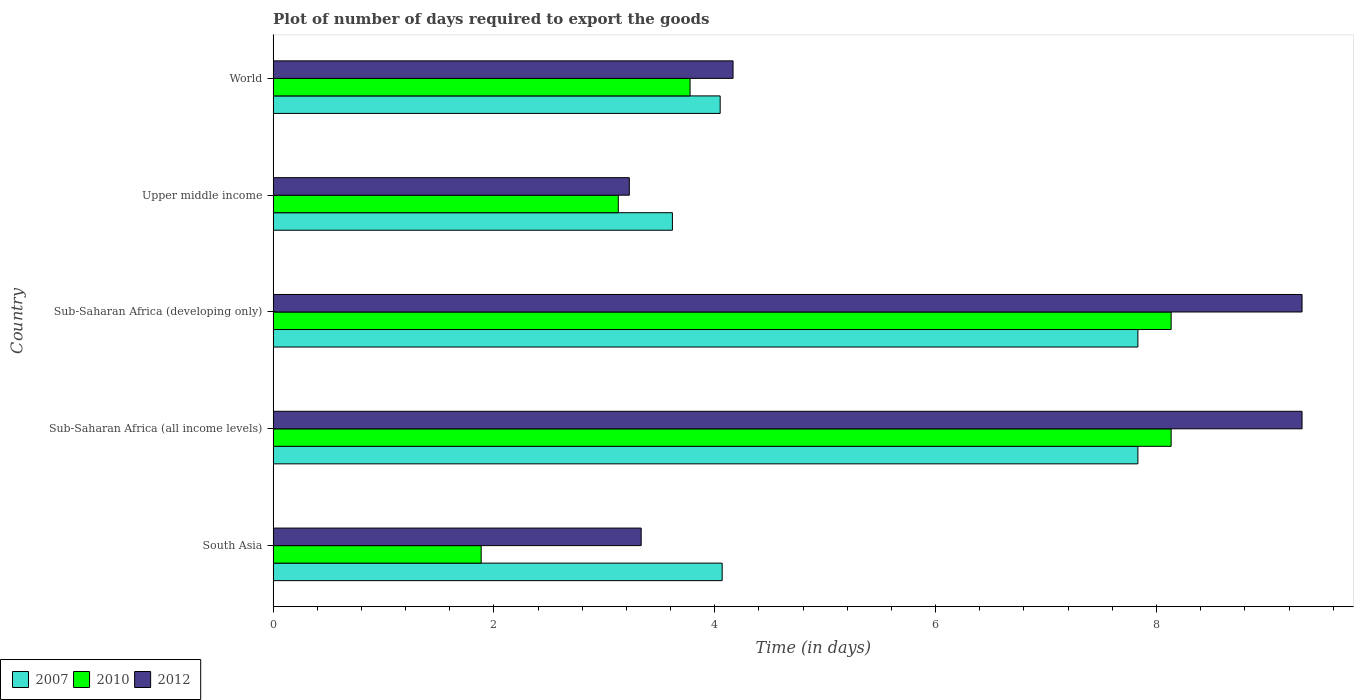How many groups of bars are there?
Give a very brief answer. 5. Are the number of bars per tick equal to the number of legend labels?
Your response must be concise. Yes. Are the number of bars on each tick of the Y-axis equal?
Ensure brevity in your answer.  Yes. How many bars are there on the 3rd tick from the top?
Make the answer very short. 3. How many bars are there on the 2nd tick from the bottom?
Offer a very short reply. 3. What is the label of the 3rd group of bars from the top?
Provide a succinct answer. Sub-Saharan Africa (developing only). In how many cases, is the number of bars for a given country not equal to the number of legend labels?
Your response must be concise. 0. What is the time required to export goods in 2010 in Sub-Saharan Africa (all income levels)?
Give a very brief answer. 8.13. Across all countries, what is the maximum time required to export goods in 2012?
Your answer should be very brief. 9.32. Across all countries, what is the minimum time required to export goods in 2012?
Give a very brief answer. 3.23. In which country was the time required to export goods in 2007 maximum?
Provide a short and direct response. Sub-Saharan Africa (all income levels). What is the total time required to export goods in 2010 in the graph?
Provide a short and direct response. 25.05. What is the difference between the time required to export goods in 2012 in South Asia and the time required to export goods in 2010 in World?
Offer a terse response. -0.44. What is the average time required to export goods in 2010 per country?
Offer a terse response. 5.01. What is the difference between the time required to export goods in 2010 and time required to export goods in 2007 in Sub-Saharan Africa (all income levels)?
Make the answer very short. 0.3. In how many countries, is the time required to export goods in 2007 greater than 9.2 days?
Provide a succinct answer. 0. What is the ratio of the time required to export goods in 2010 in Sub-Saharan Africa (all income levels) to that in Sub-Saharan Africa (developing only)?
Your response must be concise. 1. Is the time required to export goods in 2012 in Sub-Saharan Africa (all income levels) less than that in Sub-Saharan Africa (developing only)?
Give a very brief answer. No. Is the difference between the time required to export goods in 2010 in Sub-Saharan Africa (all income levels) and Upper middle income greater than the difference between the time required to export goods in 2007 in Sub-Saharan Africa (all income levels) and Upper middle income?
Ensure brevity in your answer.  Yes. What is the difference between the highest and the lowest time required to export goods in 2010?
Your answer should be very brief. 6.25. In how many countries, is the time required to export goods in 2007 greater than the average time required to export goods in 2007 taken over all countries?
Make the answer very short. 2. How many countries are there in the graph?
Offer a very short reply. 5. Are the values on the major ticks of X-axis written in scientific E-notation?
Provide a short and direct response. No. How many legend labels are there?
Your answer should be very brief. 3. How are the legend labels stacked?
Your answer should be very brief. Horizontal. What is the title of the graph?
Give a very brief answer. Plot of number of days required to export the goods. What is the label or title of the X-axis?
Offer a terse response. Time (in days). What is the Time (in days) of 2007 in South Asia?
Provide a short and direct response. 4.07. What is the Time (in days) in 2010 in South Asia?
Provide a succinct answer. 1.88. What is the Time (in days) in 2012 in South Asia?
Provide a short and direct response. 3.33. What is the Time (in days) in 2007 in Sub-Saharan Africa (all income levels)?
Offer a very short reply. 7.83. What is the Time (in days) of 2010 in Sub-Saharan Africa (all income levels)?
Provide a succinct answer. 8.13. What is the Time (in days) in 2012 in Sub-Saharan Africa (all income levels)?
Give a very brief answer. 9.32. What is the Time (in days) of 2007 in Sub-Saharan Africa (developing only)?
Offer a terse response. 7.83. What is the Time (in days) of 2010 in Sub-Saharan Africa (developing only)?
Provide a short and direct response. 8.13. What is the Time (in days) of 2012 in Sub-Saharan Africa (developing only)?
Make the answer very short. 9.32. What is the Time (in days) in 2007 in Upper middle income?
Offer a terse response. 3.62. What is the Time (in days) in 2010 in Upper middle income?
Your answer should be compact. 3.13. What is the Time (in days) in 2012 in Upper middle income?
Ensure brevity in your answer.  3.23. What is the Time (in days) of 2007 in World?
Give a very brief answer. 4.05. What is the Time (in days) of 2010 in World?
Your answer should be very brief. 3.78. What is the Time (in days) of 2012 in World?
Your answer should be very brief. 4.17. Across all countries, what is the maximum Time (in days) of 2007?
Make the answer very short. 7.83. Across all countries, what is the maximum Time (in days) in 2010?
Your answer should be very brief. 8.13. Across all countries, what is the maximum Time (in days) of 2012?
Make the answer very short. 9.32. Across all countries, what is the minimum Time (in days) of 2007?
Offer a terse response. 3.62. Across all countries, what is the minimum Time (in days) in 2010?
Keep it short and to the point. 1.88. Across all countries, what is the minimum Time (in days) of 2012?
Offer a terse response. 3.23. What is the total Time (in days) of 2007 in the graph?
Provide a short and direct response. 27.39. What is the total Time (in days) of 2010 in the graph?
Ensure brevity in your answer.  25.05. What is the total Time (in days) of 2012 in the graph?
Provide a succinct answer. 29.36. What is the difference between the Time (in days) of 2007 in South Asia and that in Sub-Saharan Africa (all income levels)?
Give a very brief answer. -3.76. What is the difference between the Time (in days) of 2010 in South Asia and that in Sub-Saharan Africa (all income levels)?
Give a very brief answer. -6.25. What is the difference between the Time (in days) in 2012 in South Asia and that in Sub-Saharan Africa (all income levels)?
Make the answer very short. -5.98. What is the difference between the Time (in days) in 2007 in South Asia and that in Sub-Saharan Africa (developing only)?
Provide a succinct answer. -3.76. What is the difference between the Time (in days) in 2010 in South Asia and that in Sub-Saharan Africa (developing only)?
Offer a terse response. -6.25. What is the difference between the Time (in days) of 2012 in South Asia and that in Sub-Saharan Africa (developing only)?
Provide a succinct answer. -5.98. What is the difference between the Time (in days) in 2007 in South Asia and that in Upper middle income?
Offer a very short reply. 0.45. What is the difference between the Time (in days) in 2010 in South Asia and that in Upper middle income?
Ensure brevity in your answer.  -1.24. What is the difference between the Time (in days) of 2012 in South Asia and that in Upper middle income?
Offer a very short reply. 0.11. What is the difference between the Time (in days) of 2007 in South Asia and that in World?
Offer a very short reply. 0.02. What is the difference between the Time (in days) in 2010 in South Asia and that in World?
Ensure brevity in your answer.  -1.89. What is the difference between the Time (in days) in 2012 in South Asia and that in World?
Keep it short and to the point. -0.83. What is the difference between the Time (in days) of 2007 in Sub-Saharan Africa (all income levels) and that in Sub-Saharan Africa (developing only)?
Offer a very short reply. 0. What is the difference between the Time (in days) in 2010 in Sub-Saharan Africa (all income levels) and that in Sub-Saharan Africa (developing only)?
Give a very brief answer. 0. What is the difference between the Time (in days) in 2007 in Sub-Saharan Africa (all income levels) and that in Upper middle income?
Provide a short and direct response. 4.22. What is the difference between the Time (in days) in 2010 in Sub-Saharan Africa (all income levels) and that in Upper middle income?
Give a very brief answer. 5.01. What is the difference between the Time (in days) in 2012 in Sub-Saharan Africa (all income levels) and that in Upper middle income?
Your answer should be compact. 6.09. What is the difference between the Time (in days) in 2007 in Sub-Saharan Africa (all income levels) and that in World?
Give a very brief answer. 3.78. What is the difference between the Time (in days) in 2010 in Sub-Saharan Africa (all income levels) and that in World?
Ensure brevity in your answer.  4.36. What is the difference between the Time (in days) in 2012 in Sub-Saharan Africa (all income levels) and that in World?
Provide a succinct answer. 5.15. What is the difference between the Time (in days) in 2007 in Sub-Saharan Africa (developing only) and that in Upper middle income?
Your answer should be very brief. 4.22. What is the difference between the Time (in days) of 2010 in Sub-Saharan Africa (developing only) and that in Upper middle income?
Your answer should be compact. 5.01. What is the difference between the Time (in days) of 2012 in Sub-Saharan Africa (developing only) and that in Upper middle income?
Offer a terse response. 6.09. What is the difference between the Time (in days) of 2007 in Sub-Saharan Africa (developing only) and that in World?
Keep it short and to the point. 3.78. What is the difference between the Time (in days) of 2010 in Sub-Saharan Africa (developing only) and that in World?
Offer a very short reply. 4.36. What is the difference between the Time (in days) of 2012 in Sub-Saharan Africa (developing only) and that in World?
Ensure brevity in your answer.  5.15. What is the difference between the Time (in days) in 2007 in Upper middle income and that in World?
Ensure brevity in your answer.  -0.43. What is the difference between the Time (in days) in 2010 in Upper middle income and that in World?
Keep it short and to the point. -0.65. What is the difference between the Time (in days) in 2012 in Upper middle income and that in World?
Provide a succinct answer. -0.94. What is the difference between the Time (in days) of 2007 in South Asia and the Time (in days) of 2010 in Sub-Saharan Africa (all income levels)?
Ensure brevity in your answer.  -4.07. What is the difference between the Time (in days) of 2007 in South Asia and the Time (in days) of 2012 in Sub-Saharan Africa (all income levels)?
Your answer should be compact. -5.25. What is the difference between the Time (in days) of 2010 in South Asia and the Time (in days) of 2012 in Sub-Saharan Africa (all income levels)?
Ensure brevity in your answer.  -7.43. What is the difference between the Time (in days) of 2007 in South Asia and the Time (in days) of 2010 in Sub-Saharan Africa (developing only)?
Provide a succinct answer. -4.07. What is the difference between the Time (in days) in 2007 in South Asia and the Time (in days) in 2012 in Sub-Saharan Africa (developing only)?
Offer a very short reply. -5.25. What is the difference between the Time (in days) of 2010 in South Asia and the Time (in days) of 2012 in Sub-Saharan Africa (developing only)?
Offer a terse response. -7.43. What is the difference between the Time (in days) of 2007 in South Asia and the Time (in days) of 2010 in Upper middle income?
Offer a terse response. 0.94. What is the difference between the Time (in days) of 2007 in South Asia and the Time (in days) of 2012 in Upper middle income?
Provide a succinct answer. 0.84. What is the difference between the Time (in days) in 2010 in South Asia and the Time (in days) in 2012 in Upper middle income?
Your answer should be very brief. -1.34. What is the difference between the Time (in days) in 2007 in South Asia and the Time (in days) in 2010 in World?
Keep it short and to the point. 0.29. What is the difference between the Time (in days) in 2007 in South Asia and the Time (in days) in 2012 in World?
Offer a terse response. -0.1. What is the difference between the Time (in days) in 2010 in South Asia and the Time (in days) in 2012 in World?
Provide a succinct answer. -2.28. What is the difference between the Time (in days) of 2007 in Sub-Saharan Africa (all income levels) and the Time (in days) of 2010 in Sub-Saharan Africa (developing only)?
Your answer should be very brief. -0.3. What is the difference between the Time (in days) of 2007 in Sub-Saharan Africa (all income levels) and the Time (in days) of 2012 in Sub-Saharan Africa (developing only)?
Ensure brevity in your answer.  -1.49. What is the difference between the Time (in days) of 2010 in Sub-Saharan Africa (all income levels) and the Time (in days) of 2012 in Sub-Saharan Africa (developing only)?
Offer a terse response. -1.19. What is the difference between the Time (in days) of 2007 in Sub-Saharan Africa (all income levels) and the Time (in days) of 2010 in Upper middle income?
Offer a terse response. 4.71. What is the difference between the Time (in days) in 2007 in Sub-Saharan Africa (all income levels) and the Time (in days) in 2012 in Upper middle income?
Your response must be concise. 4.61. What is the difference between the Time (in days) in 2010 in Sub-Saharan Africa (all income levels) and the Time (in days) in 2012 in Upper middle income?
Ensure brevity in your answer.  4.91. What is the difference between the Time (in days) of 2007 in Sub-Saharan Africa (all income levels) and the Time (in days) of 2010 in World?
Your answer should be very brief. 4.06. What is the difference between the Time (in days) in 2007 in Sub-Saharan Africa (all income levels) and the Time (in days) in 2012 in World?
Your response must be concise. 3.67. What is the difference between the Time (in days) in 2010 in Sub-Saharan Africa (all income levels) and the Time (in days) in 2012 in World?
Give a very brief answer. 3.97. What is the difference between the Time (in days) in 2007 in Sub-Saharan Africa (developing only) and the Time (in days) in 2010 in Upper middle income?
Your response must be concise. 4.71. What is the difference between the Time (in days) of 2007 in Sub-Saharan Africa (developing only) and the Time (in days) of 2012 in Upper middle income?
Offer a terse response. 4.61. What is the difference between the Time (in days) in 2010 in Sub-Saharan Africa (developing only) and the Time (in days) in 2012 in Upper middle income?
Make the answer very short. 4.91. What is the difference between the Time (in days) of 2007 in Sub-Saharan Africa (developing only) and the Time (in days) of 2010 in World?
Provide a short and direct response. 4.06. What is the difference between the Time (in days) of 2007 in Sub-Saharan Africa (developing only) and the Time (in days) of 2012 in World?
Offer a very short reply. 3.67. What is the difference between the Time (in days) of 2010 in Sub-Saharan Africa (developing only) and the Time (in days) of 2012 in World?
Provide a short and direct response. 3.97. What is the difference between the Time (in days) of 2007 in Upper middle income and the Time (in days) of 2010 in World?
Provide a short and direct response. -0.16. What is the difference between the Time (in days) of 2007 in Upper middle income and the Time (in days) of 2012 in World?
Offer a terse response. -0.55. What is the difference between the Time (in days) in 2010 in Upper middle income and the Time (in days) in 2012 in World?
Provide a succinct answer. -1.04. What is the average Time (in days) in 2007 per country?
Offer a terse response. 5.48. What is the average Time (in days) in 2010 per country?
Offer a terse response. 5.01. What is the average Time (in days) in 2012 per country?
Keep it short and to the point. 5.87. What is the difference between the Time (in days) of 2007 and Time (in days) of 2010 in South Asia?
Offer a terse response. 2.18. What is the difference between the Time (in days) in 2007 and Time (in days) in 2012 in South Asia?
Offer a very short reply. 0.73. What is the difference between the Time (in days) of 2010 and Time (in days) of 2012 in South Asia?
Keep it short and to the point. -1.45. What is the difference between the Time (in days) of 2007 and Time (in days) of 2010 in Sub-Saharan Africa (all income levels)?
Ensure brevity in your answer.  -0.3. What is the difference between the Time (in days) of 2007 and Time (in days) of 2012 in Sub-Saharan Africa (all income levels)?
Offer a very short reply. -1.49. What is the difference between the Time (in days) of 2010 and Time (in days) of 2012 in Sub-Saharan Africa (all income levels)?
Your answer should be compact. -1.19. What is the difference between the Time (in days) in 2007 and Time (in days) in 2010 in Sub-Saharan Africa (developing only)?
Your answer should be compact. -0.3. What is the difference between the Time (in days) in 2007 and Time (in days) in 2012 in Sub-Saharan Africa (developing only)?
Your answer should be compact. -1.49. What is the difference between the Time (in days) in 2010 and Time (in days) in 2012 in Sub-Saharan Africa (developing only)?
Ensure brevity in your answer.  -1.19. What is the difference between the Time (in days) of 2007 and Time (in days) of 2010 in Upper middle income?
Keep it short and to the point. 0.49. What is the difference between the Time (in days) of 2007 and Time (in days) of 2012 in Upper middle income?
Offer a terse response. 0.39. What is the difference between the Time (in days) in 2010 and Time (in days) in 2012 in Upper middle income?
Make the answer very short. -0.1. What is the difference between the Time (in days) in 2007 and Time (in days) in 2010 in World?
Your response must be concise. 0.27. What is the difference between the Time (in days) of 2007 and Time (in days) of 2012 in World?
Offer a terse response. -0.12. What is the difference between the Time (in days) of 2010 and Time (in days) of 2012 in World?
Provide a succinct answer. -0.39. What is the ratio of the Time (in days) in 2007 in South Asia to that in Sub-Saharan Africa (all income levels)?
Ensure brevity in your answer.  0.52. What is the ratio of the Time (in days) in 2010 in South Asia to that in Sub-Saharan Africa (all income levels)?
Ensure brevity in your answer.  0.23. What is the ratio of the Time (in days) of 2012 in South Asia to that in Sub-Saharan Africa (all income levels)?
Offer a terse response. 0.36. What is the ratio of the Time (in days) of 2007 in South Asia to that in Sub-Saharan Africa (developing only)?
Provide a short and direct response. 0.52. What is the ratio of the Time (in days) of 2010 in South Asia to that in Sub-Saharan Africa (developing only)?
Provide a succinct answer. 0.23. What is the ratio of the Time (in days) in 2012 in South Asia to that in Sub-Saharan Africa (developing only)?
Offer a terse response. 0.36. What is the ratio of the Time (in days) of 2007 in South Asia to that in Upper middle income?
Offer a very short reply. 1.12. What is the ratio of the Time (in days) in 2010 in South Asia to that in Upper middle income?
Provide a short and direct response. 0.6. What is the ratio of the Time (in days) of 2012 in South Asia to that in Upper middle income?
Your answer should be very brief. 1.03. What is the ratio of the Time (in days) in 2007 in South Asia to that in World?
Offer a terse response. 1. What is the ratio of the Time (in days) of 2010 in South Asia to that in World?
Offer a terse response. 0.5. What is the ratio of the Time (in days) of 2012 in South Asia to that in World?
Your response must be concise. 0.8. What is the ratio of the Time (in days) of 2007 in Sub-Saharan Africa (all income levels) to that in Sub-Saharan Africa (developing only)?
Offer a terse response. 1. What is the ratio of the Time (in days) of 2010 in Sub-Saharan Africa (all income levels) to that in Sub-Saharan Africa (developing only)?
Your response must be concise. 1. What is the ratio of the Time (in days) in 2007 in Sub-Saharan Africa (all income levels) to that in Upper middle income?
Provide a short and direct response. 2.17. What is the ratio of the Time (in days) in 2010 in Sub-Saharan Africa (all income levels) to that in Upper middle income?
Your answer should be compact. 2.6. What is the ratio of the Time (in days) in 2012 in Sub-Saharan Africa (all income levels) to that in Upper middle income?
Your answer should be very brief. 2.89. What is the ratio of the Time (in days) of 2007 in Sub-Saharan Africa (all income levels) to that in World?
Your answer should be very brief. 1.93. What is the ratio of the Time (in days) of 2010 in Sub-Saharan Africa (all income levels) to that in World?
Keep it short and to the point. 2.15. What is the ratio of the Time (in days) in 2012 in Sub-Saharan Africa (all income levels) to that in World?
Your answer should be compact. 2.24. What is the ratio of the Time (in days) in 2007 in Sub-Saharan Africa (developing only) to that in Upper middle income?
Your answer should be compact. 2.17. What is the ratio of the Time (in days) of 2010 in Sub-Saharan Africa (developing only) to that in Upper middle income?
Give a very brief answer. 2.6. What is the ratio of the Time (in days) in 2012 in Sub-Saharan Africa (developing only) to that in Upper middle income?
Give a very brief answer. 2.89. What is the ratio of the Time (in days) in 2007 in Sub-Saharan Africa (developing only) to that in World?
Offer a terse response. 1.93. What is the ratio of the Time (in days) of 2010 in Sub-Saharan Africa (developing only) to that in World?
Offer a terse response. 2.15. What is the ratio of the Time (in days) in 2012 in Sub-Saharan Africa (developing only) to that in World?
Make the answer very short. 2.24. What is the ratio of the Time (in days) of 2007 in Upper middle income to that in World?
Ensure brevity in your answer.  0.89. What is the ratio of the Time (in days) in 2010 in Upper middle income to that in World?
Keep it short and to the point. 0.83. What is the ratio of the Time (in days) in 2012 in Upper middle income to that in World?
Provide a short and direct response. 0.77. What is the difference between the highest and the second highest Time (in days) of 2010?
Your answer should be very brief. 0. What is the difference between the highest and the second highest Time (in days) in 2012?
Offer a very short reply. 0. What is the difference between the highest and the lowest Time (in days) in 2007?
Keep it short and to the point. 4.22. What is the difference between the highest and the lowest Time (in days) in 2010?
Make the answer very short. 6.25. What is the difference between the highest and the lowest Time (in days) in 2012?
Offer a very short reply. 6.09. 